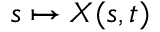Convert formula to latex. <formula><loc_0><loc_0><loc_500><loc_500>s \mapsto { X } ( s , t )</formula> 